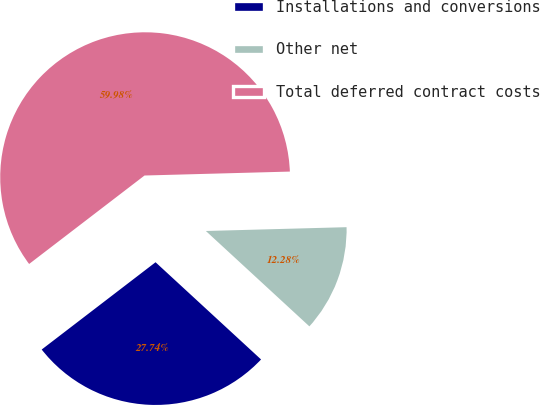Convert chart. <chart><loc_0><loc_0><loc_500><loc_500><pie_chart><fcel>Installations and conversions<fcel>Other net<fcel>Total deferred contract costs<nl><fcel>27.74%<fcel>12.28%<fcel>59.98%<nl></chart> 